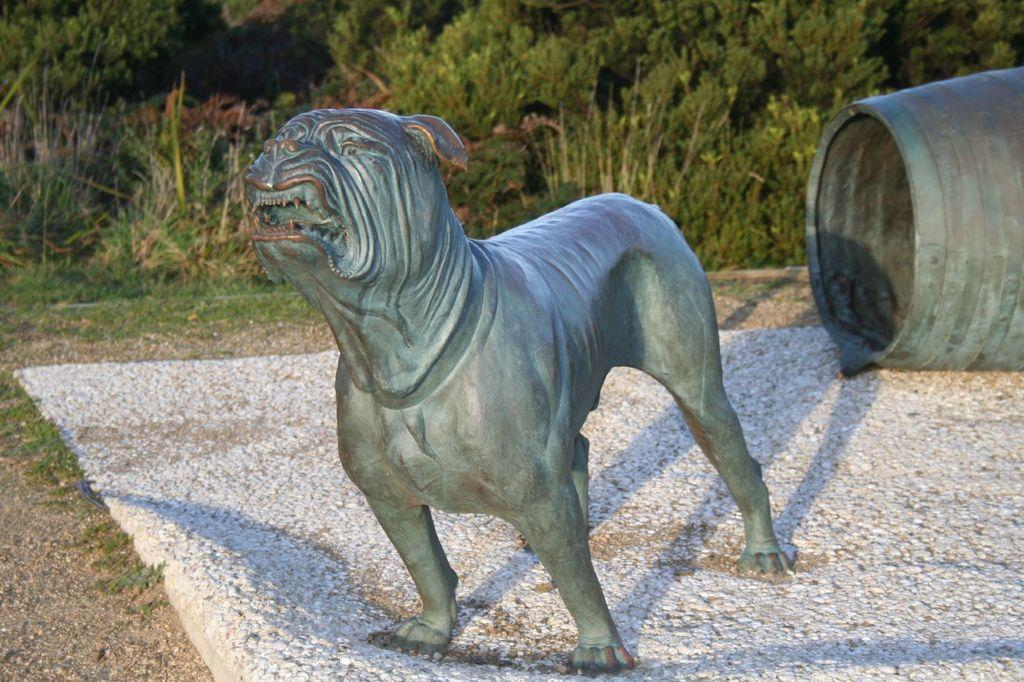What is the main subject of the image? There is a statue of a dog in the image. What is at the base of the statue? There is a barrel at the bottom of the statue. What can be seen in the background of the image? There are trees, plants, and grass in the background of the image. What type of jeans is the dog wearing in the image? There is no dog wearing jeans in the image; it is a statue of a dog. 